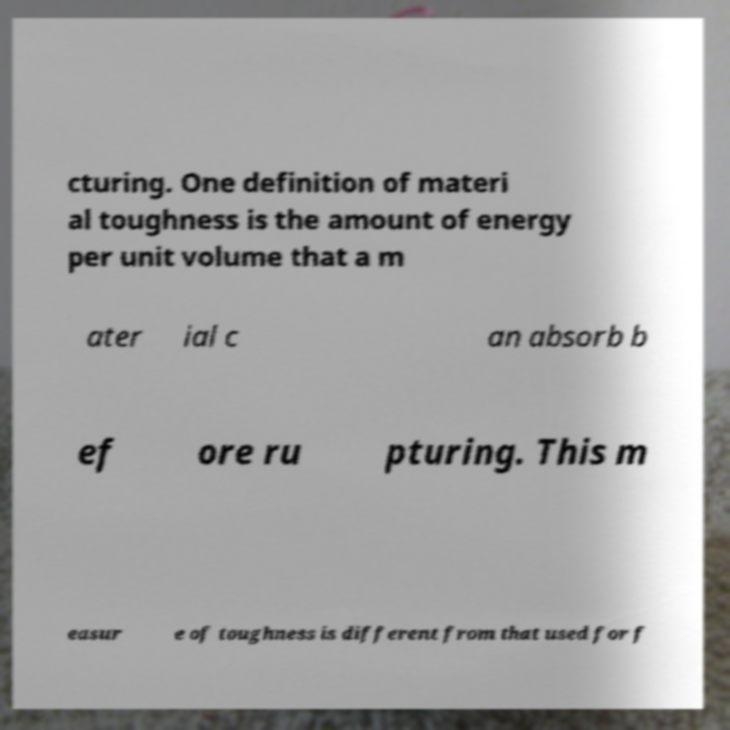What messages or text are displayed in this image? I need them in a readable, typed format. cturing. One definition of materi al toughness is the amount of energy per unit volume that a m ater ial c an absorb b ef ore ru pturing. This m easur e of toughness is different from that used for f 